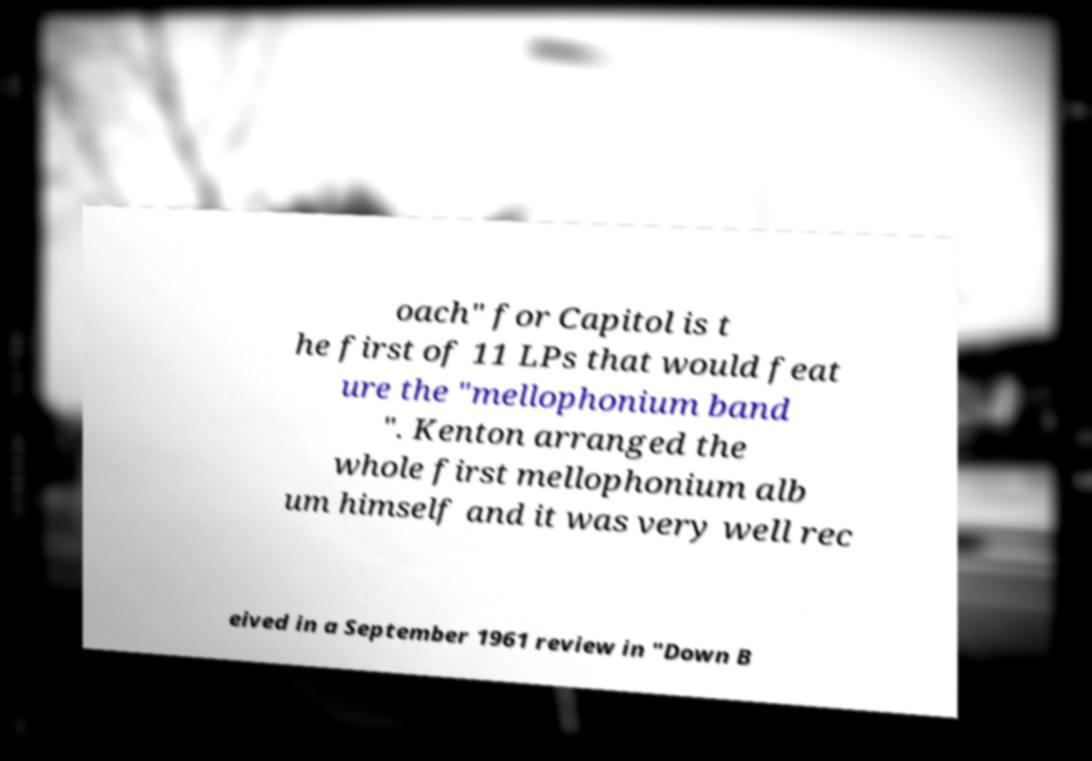Please read and relay the text visible in this image. What does it say? oach" for Capitol is t he first of 11 LPs that would feat ure the "mellophonium band ". Kenton arranged the whole first mellophonium alb um himself and it was very well rec eived in a September 1961 review in "Down B 